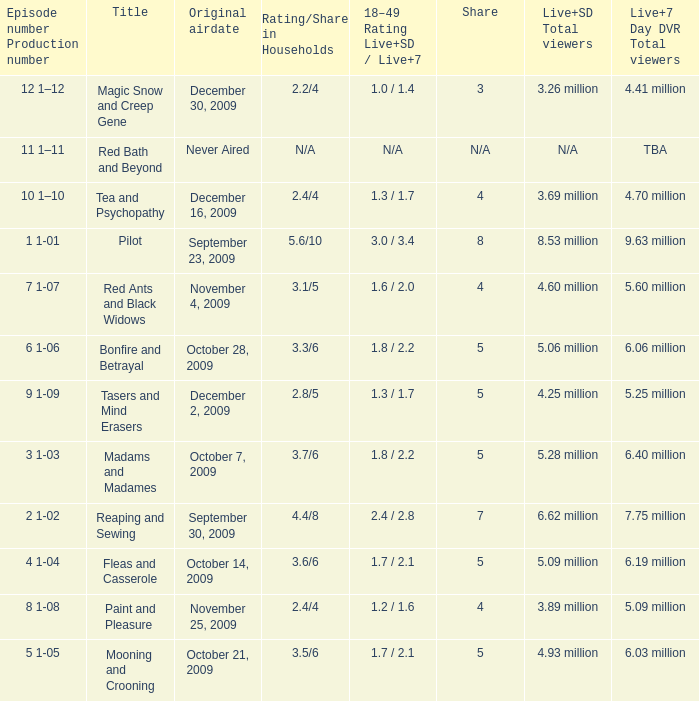When did the episode that had 3.69 million total viewers (Live and SD types combined) first air? December 16, 2009. 